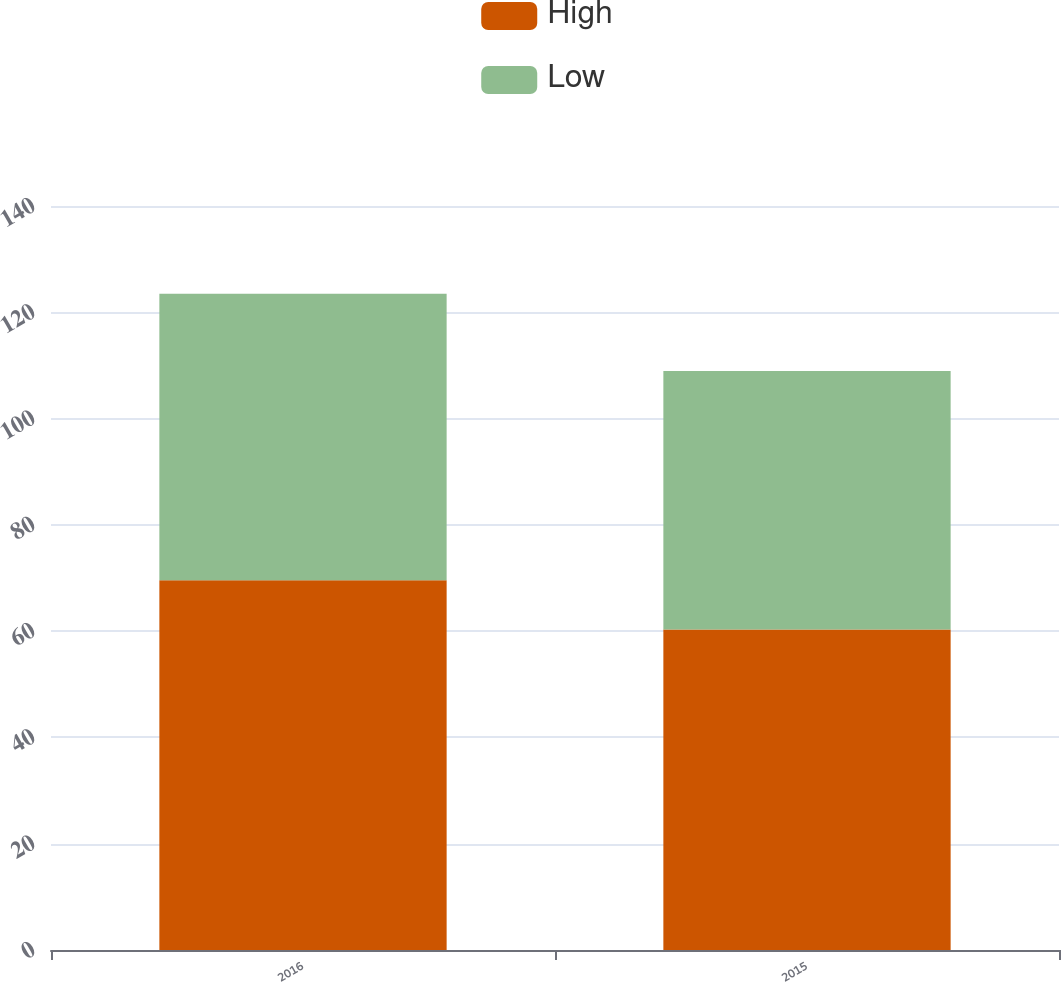Convert chart. <chart><loc_0><loc_0><loc_500><loc_500><stacked_bar_chart><ecel><fcel>2016<fcel>2015<nl><fcel>High<fcel>69.59<fcel>60.3<nl><fcel>Low<fcel>53.88<fcel>48.66<nl></chart> 